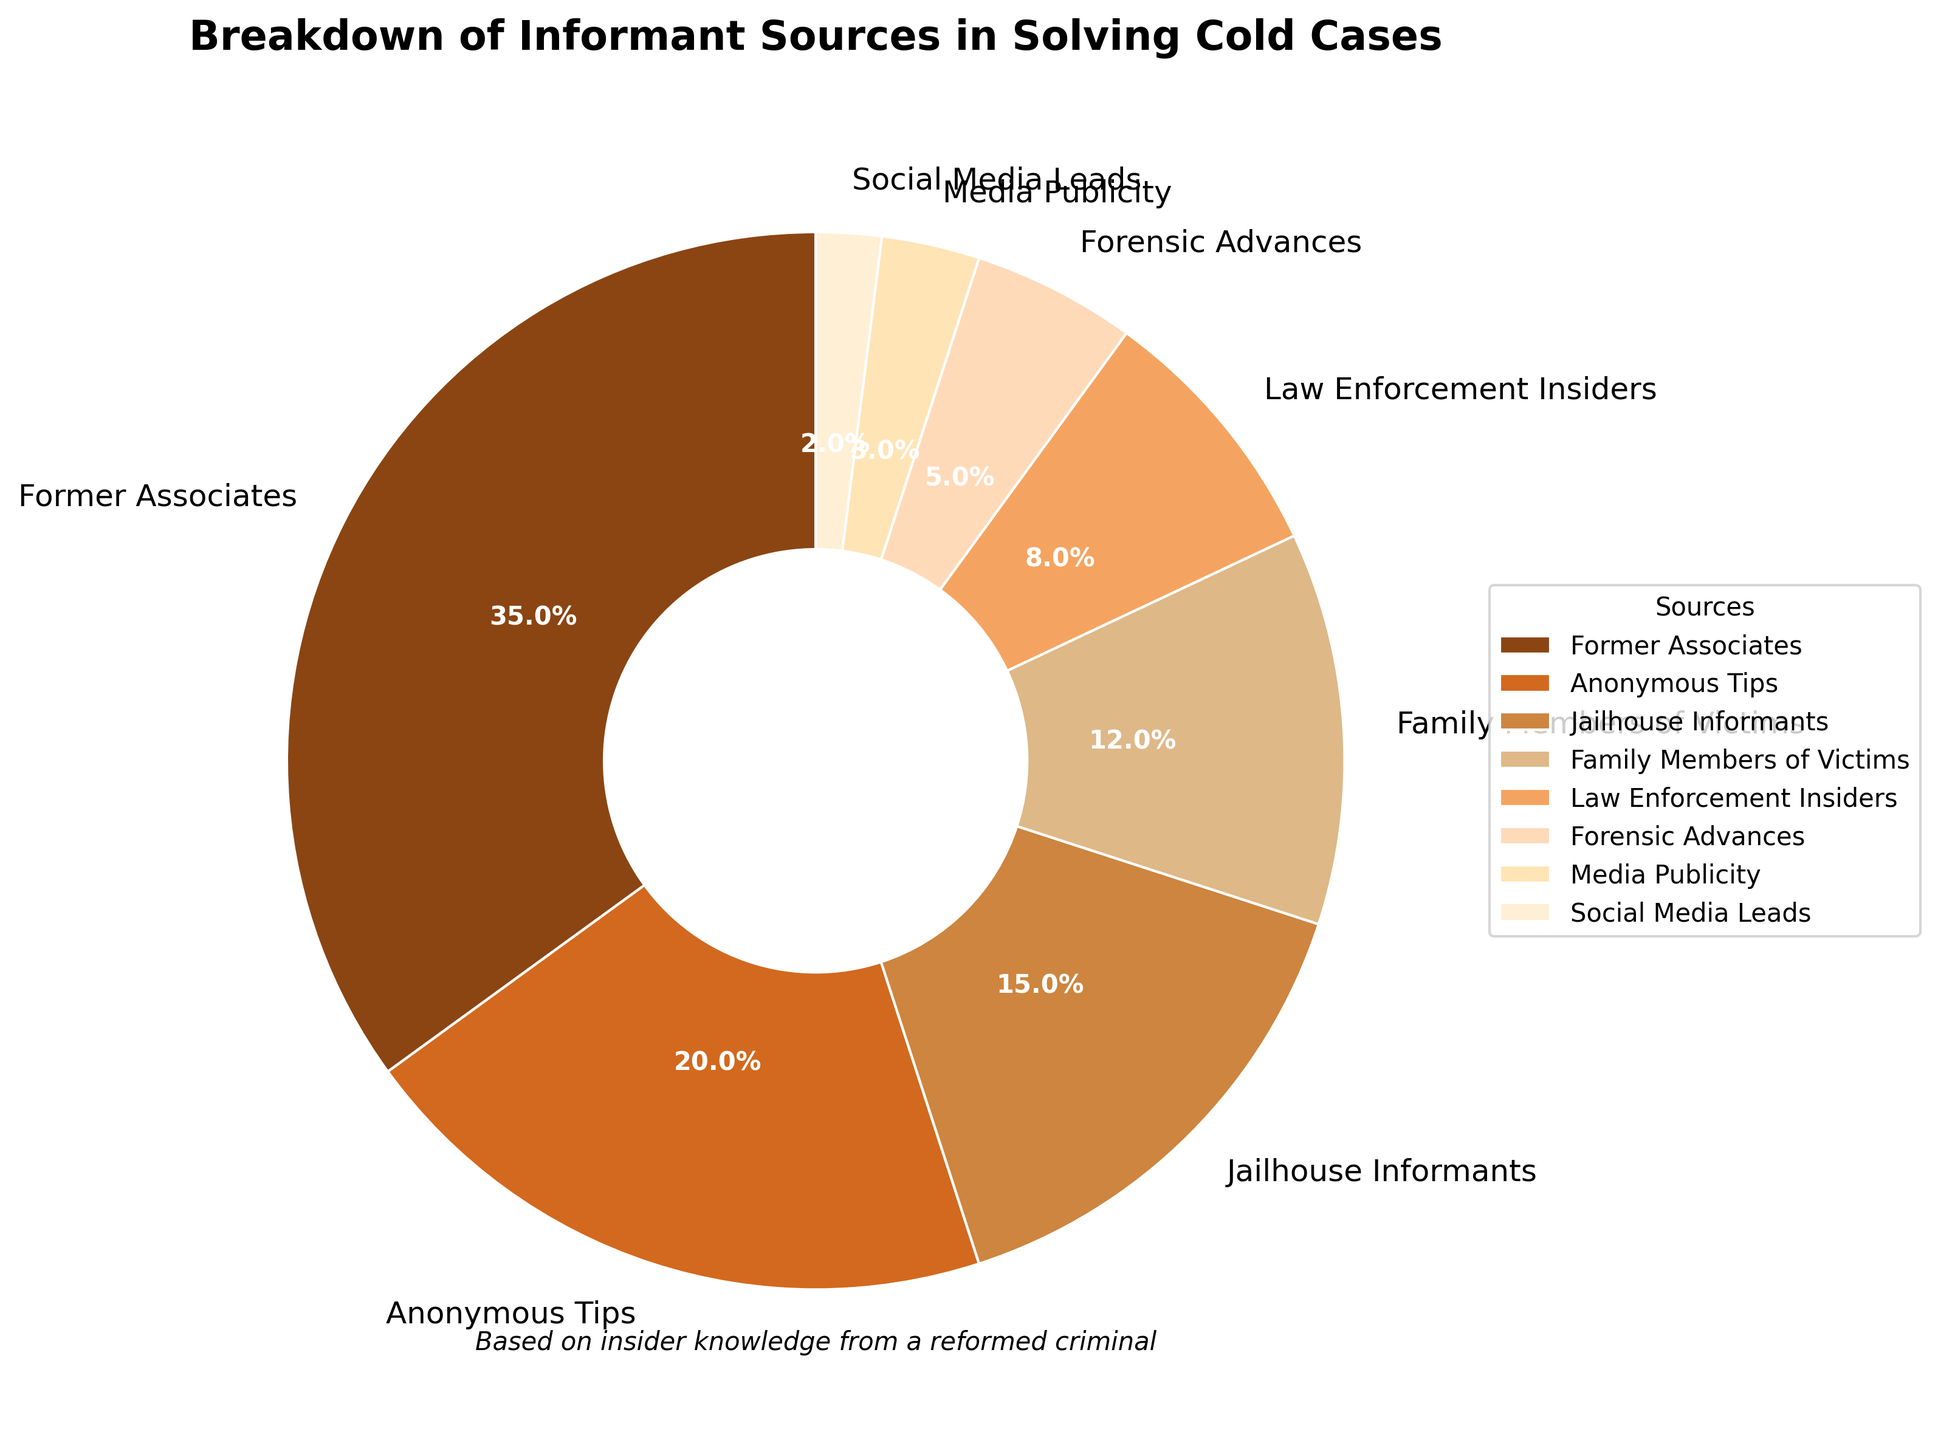Which source contributes the highest percentage to solving cold cases? The section labeled "Former Associates" has the largest percentage, 35%, which is the highest in the pie chart.
Answer: Former Associates Which two sources together account for more than half of the solved cold cases? Summing the percentages of "Former Associates" (35%) and "Anonymous Tips" (20%) gives 55%, which is more than half.
Answer: Former Associates and Anonymous Tips What percentage of informant sources come from family-related connections (Family Members of Victims)? The "Family Members of Victims" section shows 12%.
Answer: 12% How does the contribution of Jailhouse Informants compare to that of Law Enforcement Insiders? Jailhouse Informants account for 15%, while Law Enforcement Insiders account for 8%. Jailhouse Informants contribute more.
Answer: Jailhouse Informants contribute more Which source has the smallest contribution to solving cold cases? The "Social Media Leads" section has the smallest percentage, 2%.
Answer: Social Media Leads If you add the contributions of Forensic Advances, Media Publicity, and Social Media Leads, what percentage do they account for? Adding the percentages: Forensic Advances (5%), Media Publicity (3%), and Social Media Leads (2%) gives 5% + 3% + 2% = 10%.
Answer: 10% What is the difference in percentage between Former Associates and Family Members of Victims? Subtracting the percentage of "Family Members of Victims" (12%) from "Former Associates" (35%) gives 35% - 12% = 23%.
Answer: 23% How many sources contribute less than 10% each to solving cold cases? The sources contributing less than 10% are "Law Enforcement Insiders" (8%), "Forensic Advances" (5%), "Media Publicity" (3%), and "Social Media Leads" (2%). There are 4 such sources.
Answer: 4 sources Out of Anonymous Tips and Jailhouse Informants, which has a higher percentage and by how much? "Anonymous Tips" account for 20%, and "Jailhouse Informants" account for 15%. The difference is 20% - 15% = 5%.
Answer: Anonymous Tips by 5% 